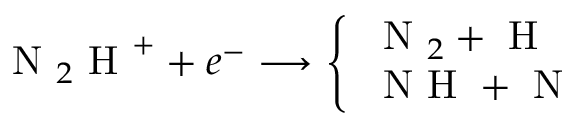Convert formula to latex. <formula><loc_0><loc_0><loc_500><loc_500>N _ { 2 } H ^ { + } + e ^ { - } \longrightarrow \left \{ \begin{array} { l l } { N _ { 2 } + H } \\ { N H + N } \end{array}</formula> 